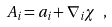<formula> <loc_0><loc_0><loc_500><loc_500>A _ { i } = a _ { i } + \nabla _ { i } \chi \ ,</formula> 